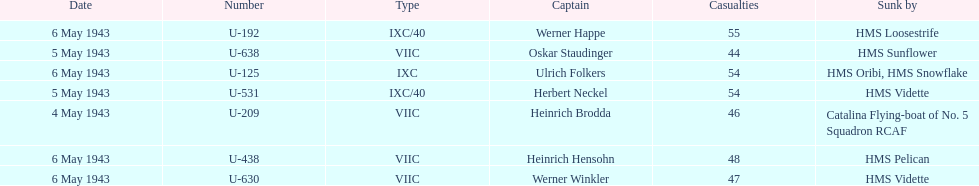What is the only vessel to sink multiple u-boats? HMS Vidette. 